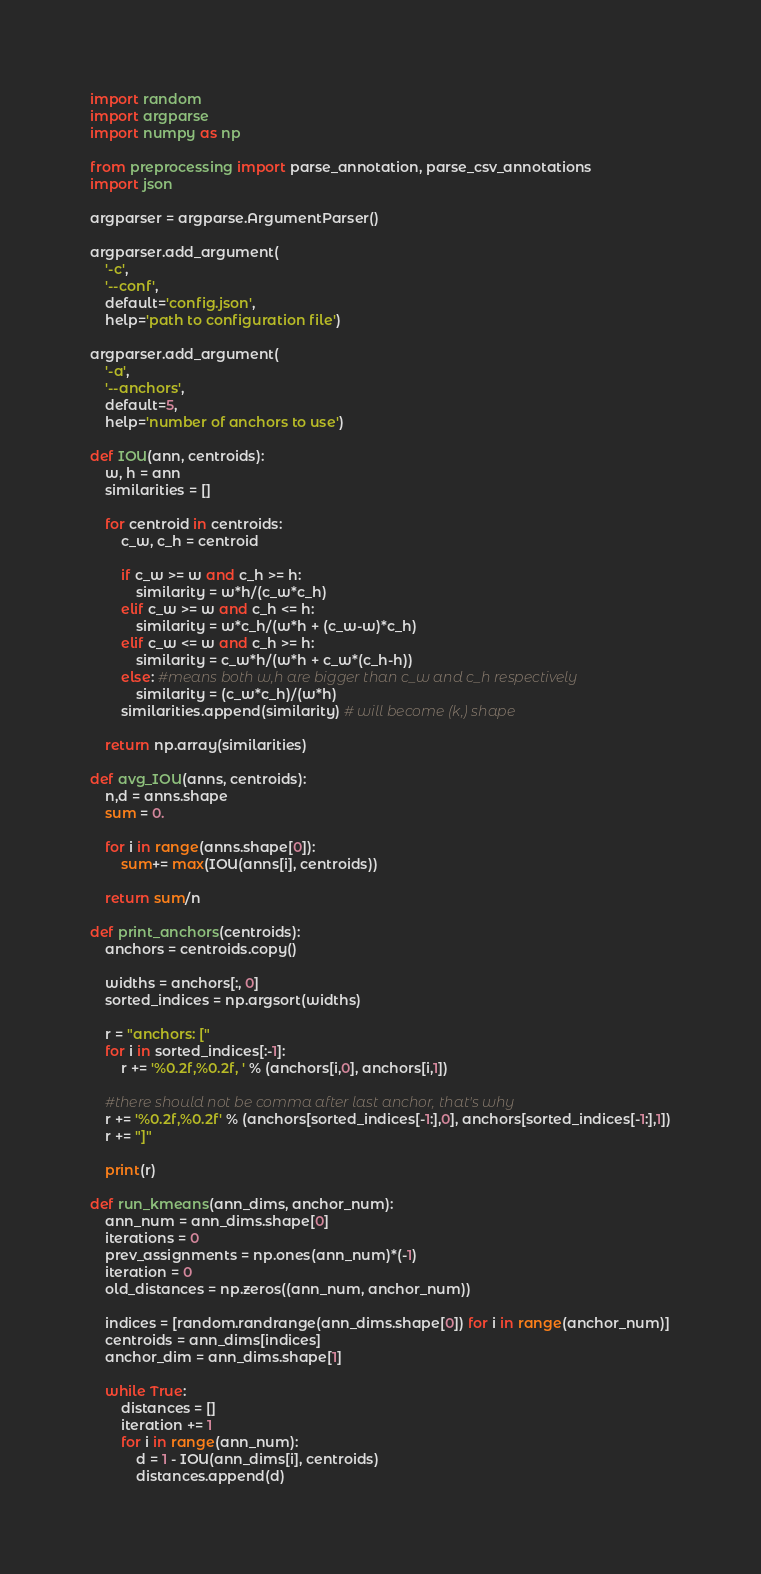Convert code to text. <code><loc_0><loc_0><loc_500><loc_500><_Python_>import random
import argparse
import numpy as np

from preprocessing import parse_annotation, parse_csv_annotations
import json

argparser = argparse.ArgumentParser()

argparser.add_argument(
    '-c',
    '--conf',
    default='config.json',
    help='path to configuration file')

argparser.add_argument(
    '-a',
    '--anchors',
    default=5,
    help='number of anchors to use')

def IOU(ann, centroids):
    w, h = ann
    similarities = []

    for centroid in centroids:
        c_w, c_h = centroid

        if c_w >= w and c_h >= h:
            similarity = w*h/(c_w*c_h)
        elif c_w >= w and c_h <= h:
            similarity = w*c_h/(w*h + (c_w-w)*c_h)
        elif c_w <= w and c_h >= h:
            similarity = c_w*h/(w*h + c_w*(c_h-h))
        else: #means both w,h are bigger than c_w and c_h respectively
            similarity = (c_w*c_h)/(w*h)
        similarities.append(similarity) # will become (k,) shape

    return np.array(similarities)

def avg_IOU(anns, centroids):
    n,d = anns.shape
    sum = 0.

    for i in range(anns.shape[0]):
        sum+= max(IOU(anns[i], centroids))

    return sum/n

def print_anchors(centroids):
    anchors = centroids.copy()

    widths = anchors[:, 0]
    sorted_indices = np.argsort(widths)

    r = "anchors: ["
    for i in sorted_indices[:-1]:
        r += '%0.2f,%0.2f, ' % (anchors[i,0], anchors[i,1])

    #there should not be comma after last anchor, that's why
    r += '%0.2f,%0.2f' % (anchors[sorted_indices[-1:],0], anchors[sorted_indices[-1:],1])
    r += "]"

    print(r)

def run_kmeans(ann_dims, anchor_num):
    ann_num = ann_dims.shape[0]
    iterations = 0
    prev_assignments = np.ones(ann_num)*(-1)
    iteration = 0
    old_distances = np.zeros((ann_num, anchor_num))

    indices = [random.randrange(ann_dims.shape[0]) for i in range(anchor_num)]
    centroids = ann_dims[indices]
    anchor_dim = ann_dims.shape[1]

    while True:
        distances = []
        iteration += 1
        for i in range(ann_num):
            d = 1 - IOU(ann_dims[i], centroids)
            distances.append(d)</code> 